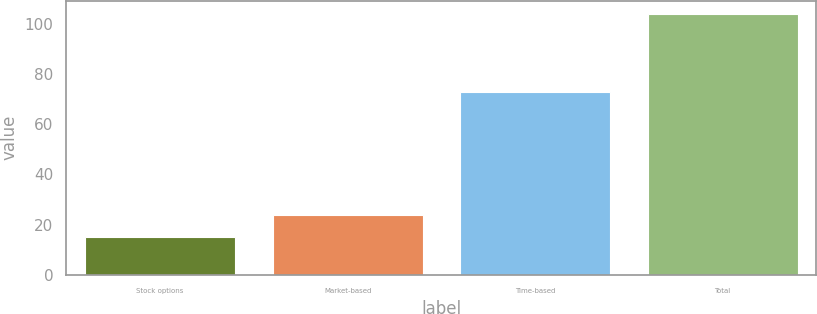<chart> <loc_0><loc_0><loc_500><loc_500><bar_chart><fcel>Stock options<fcel>Market-based<fcel>Time-based<fcel>Total<nl><fcel>15<fcel>23.9<fcel>73<fcel>104<nl></chart> 